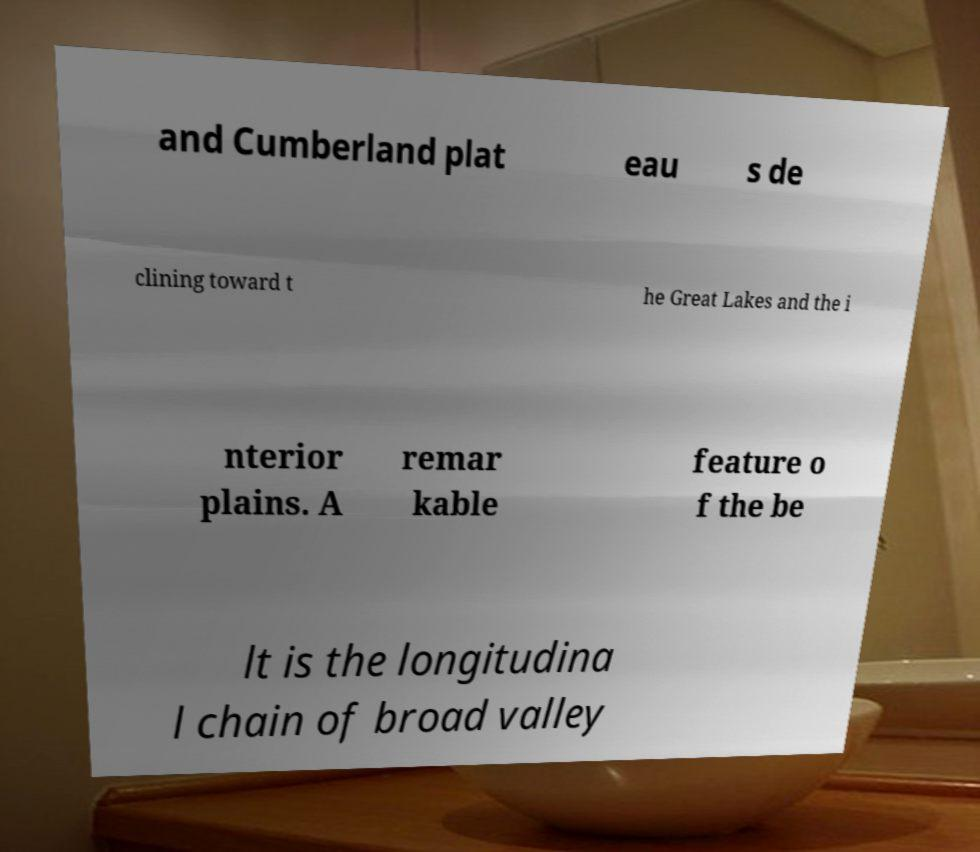What messages or text are displayed in this image? I need them in a readable, typed format. and Cumberland plat eau s de clining toward t he Great Lakes and the i nterior plains. A remar kable feature o f the be lt is the longitudina l chain of broad valley 